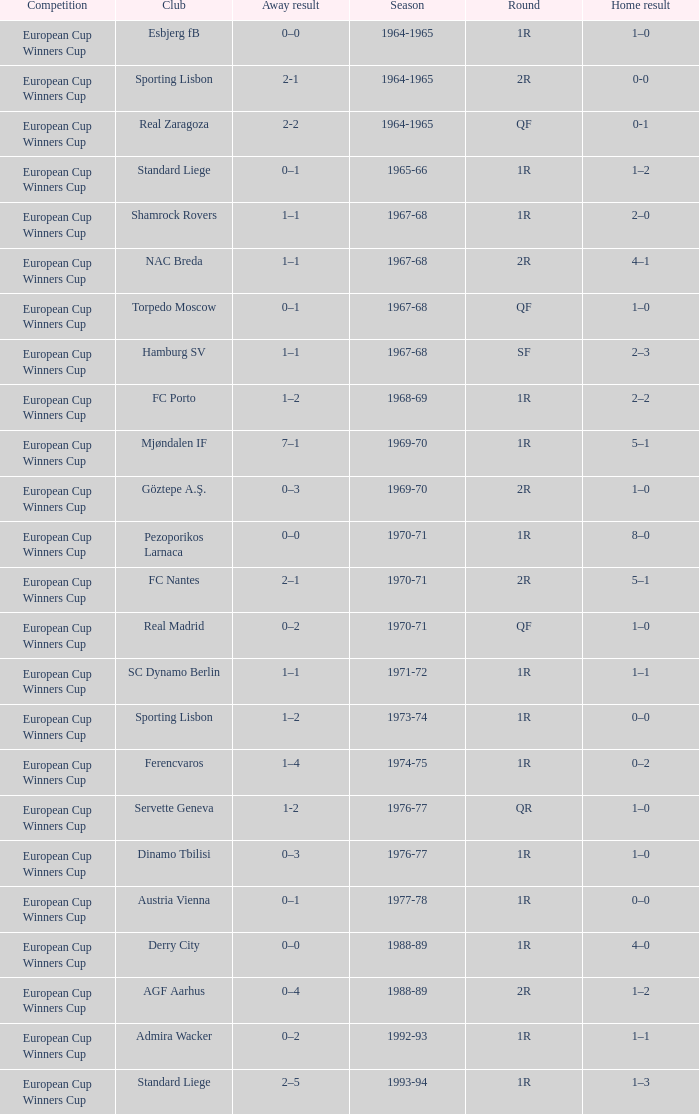Round of 2r, and a Home result of 0-0 has what season? 1964-1965. 